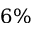Convert formula to latex. <formula><loc_0><loc_0><loc_500><loc_500>6 \%</formula> 